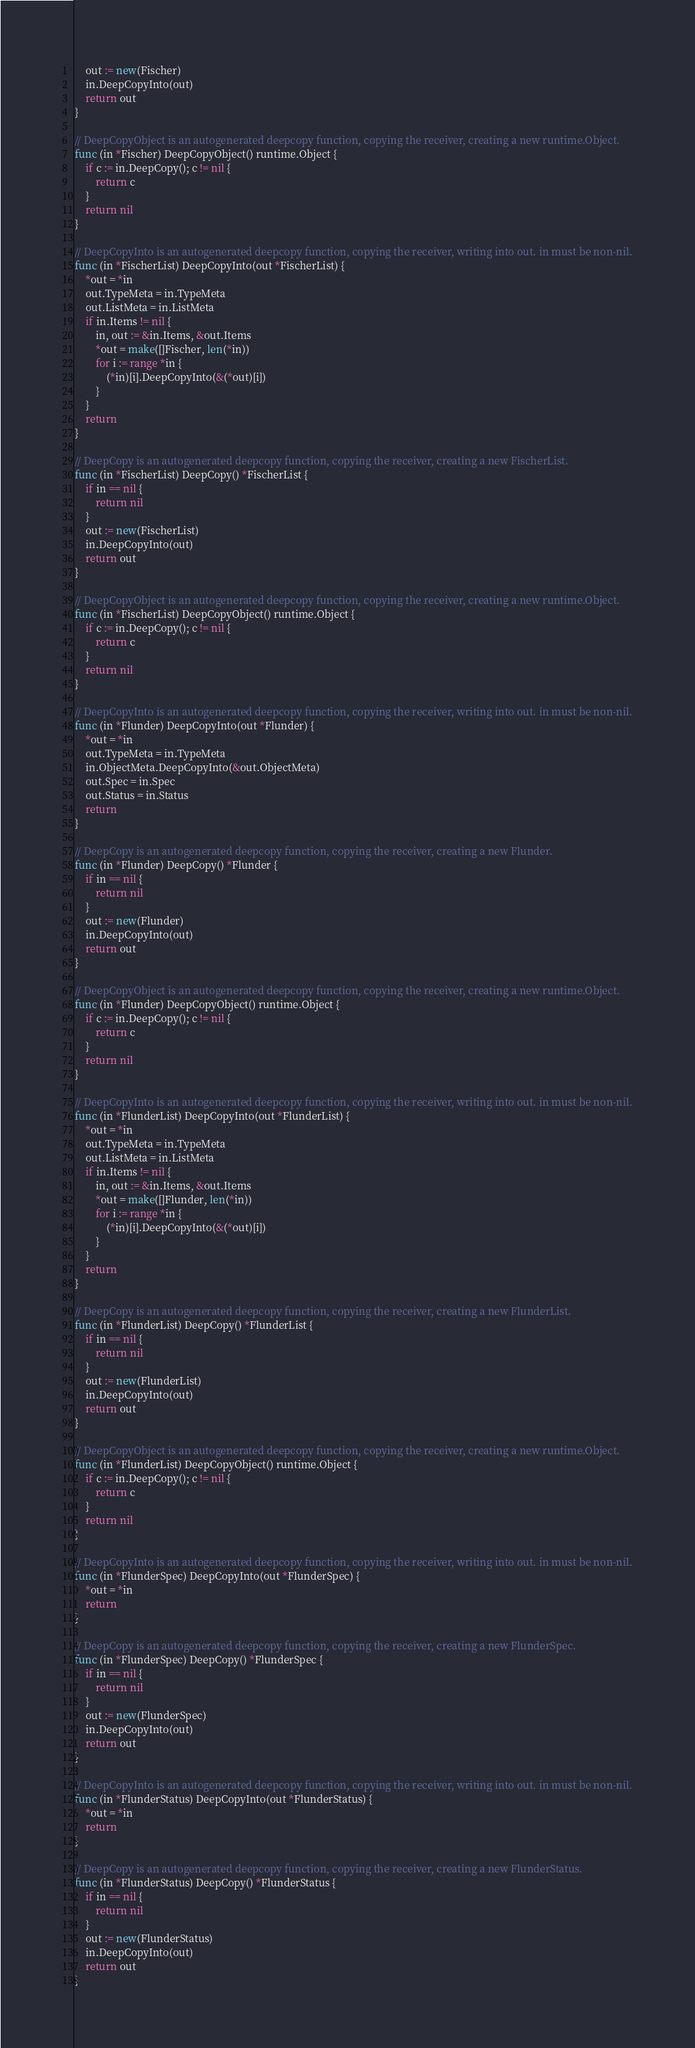Convert code to text. <code><loc_0><loc_0><loc_500><loc_500><_Go_>	out := new(Fischer)
	in.DeepCopyInto(out)
	return out
}

// DeepCopyObject is an autogenerated deepcopy function, copying the receiver, creating a new runtime.Object.
func (in *Fischer) DeepCopyObject() runtime.Object {
	if c := in.DeepCopy(); c != nil {
		return c
	}
	return nil
}

// DeepCopyInto is an autogenerated deepcopy function, copying the receiver, writing into out. in must be non-nil.
func (in *FischerList) DeepCopyInto(out *FischerList) {
	*out = *in
	out.TypeMeta = in.TypeMeta
	out.ListMeta = in.ListMeta
	if in.Items != nil {
		in, out := &in.Items, &out.Items
		*out = make([]Fischer, len(*in))
		for i := range *in {
			(*in)[i].DeepCopyInto(&(*out)[i])
		}
	}
	return
}

// DeepCopy is an autogenerated deepcopy function, copying the receiver, creating a new FischerList.
func (in *FischerList) DeepCopy() *FischerList {
	if in == nil {
		return nil
	}
	out := new(FischerList)
	in.DeepCopyInto(out)
	return out
}

// DeepCopyObject is an autogenerated deepcopy function, copying the receiver, creating a new runtime.Object.
func (in *FischerList) DeepCopyObject() runtime.Object {
	if c := in.DeepCopy(); c != nil {
		return c
	}
	return nil
}

// DeepCopyInto is an autogenerated deepcopy function, copying the receiver, writing into out. in must be non-nil.
func (in *Flunder) DeepCopyInto(out *Flunder) {
	*out = *in
	out.TypeMeta = in.TypeMeta
	in.ObjectMeta.DeepCopyInto(&out.ObjectMeta)
	out.Spec = in.Spec
	out.Status = in.Status
	return
}

// DeepCopy is an autogenerated deepcopy function, copying the receiver, creating a new Flunder.
func (in *Flunder) DeepCopy() *Flunder {
	if in == nil {
		return nil
	}
	out := new(Flunder)
	in.DeepCopyInto(out)
	return out
}

// DeepCopyObject is an autogenerated deepcopy function, copying the receiver, creating a new runtime.Object.
func (in *Flunder) DeepCopyObject() runtime.Object {
	if c := in.DeepCopy(); c != nil {
		return c
	}
	return nil
}

// DeepCopyInto is an autogenerated deepcopy function, copying the receiver, writing into out. in must be non-nil.
func (in *FlunderList) DeepCopyInto(out *FlunderList) {
	*out = *in
	out.TypeMeta = in.TypeMeta
	out.ListMeta = in.ListMeta
	if in.Items != nil {
		in, out := &in.Items, &out.Items
		*out = make([]Flunder, len(*in))
		for i := range *in {
			(*in)[i].DeepCopyInto(&(*out)[i])
		}
	}
	return
}

// DeepCopy is an autogenerated deepcopy function, copying the receiver, creating a new FlunderList.
func (in *FlunderList) DeepCopy() *FlunderList {
	if in == nil {
		return nil
	}
	out := new(FlunderList)
	in.DeepCopyInto(out)
	return out
}

// DeepCopyObject is an autogenerated deepcopy function, copying the receiver, creating a new runtime.Object.
func (in *FlunderList) DeepCopyObject() runtime.Object {
	if c := in.DeepCopy(); c != nil {
		return c
	}
	return nil
}

// DeepCopyInto is an autogenerated deepcopy function, copying the receiver, writing into out. in must be non-nil.
func (in *FlunderSpec) DeepCopyInto(out *FlunderSpec) {
	*out = *in
	return
}

// DeepCopy is an autogenerated deepcopy function, copying the receiver, creating a new FlunderSpec.
func (in *FlunderSpec) DeepCopy() *FlunderSpec {
	if in == nil {
		return nil
	}
	out := new(FlunderSpec)
	in.DeepCopyInto(out)
	return out
}

// DeepCopyInto is an autogenerated deepcopy function, copying the receiver, writing into out. in must be non-nil.
func (in *FlunderStatus) DeepCopyInto(out *FlunderStatus) {
	*out = *in
	return
}

// DeepCopy is an autogenerated deepcopy function, copying the receiver, creating a new FlunderStatus.
func (in *FlunderStatus) DeepCopy() *FlunderStatus {
	if in == nil {
		return nil
	}
	out := new(FlunderStatus)
	in.DeepCopyInto(out)
	return out
}
</code> 